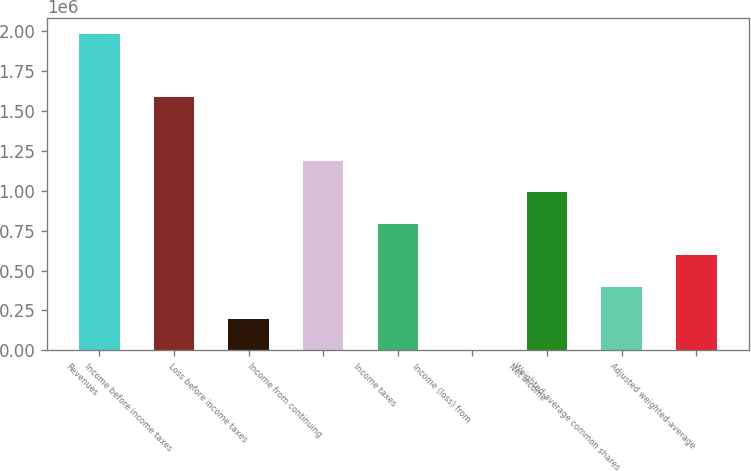Convert chart. <chart><loc_0><loc_0><loc_500><loc_500><bar_chart><fcel>Revenues<fcel>Income before income taxes<fcel>Loss before income taxes<fcel>Income from continuing<fcel>Income taxes<fcel>Income (loss) from<fcel>Net income<fcel>Weighted-average common shares<fcel>Adjusted weighted-average<nl><fcel>1.98067e+06<fcel>1.58456e+06<fcel>198152<fcel>1.18844e+06<fcel>792325<fcel>95<fcel>990382<fcel>396210<fcel>594268<nl></chart> 